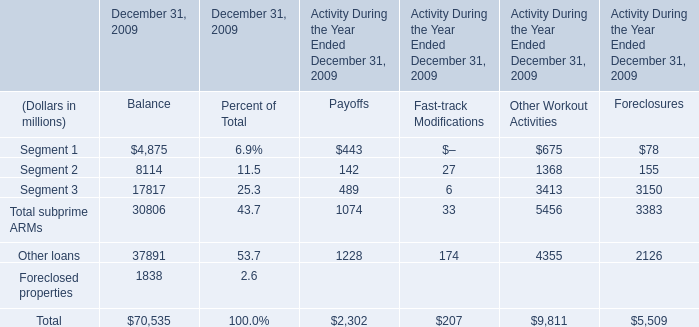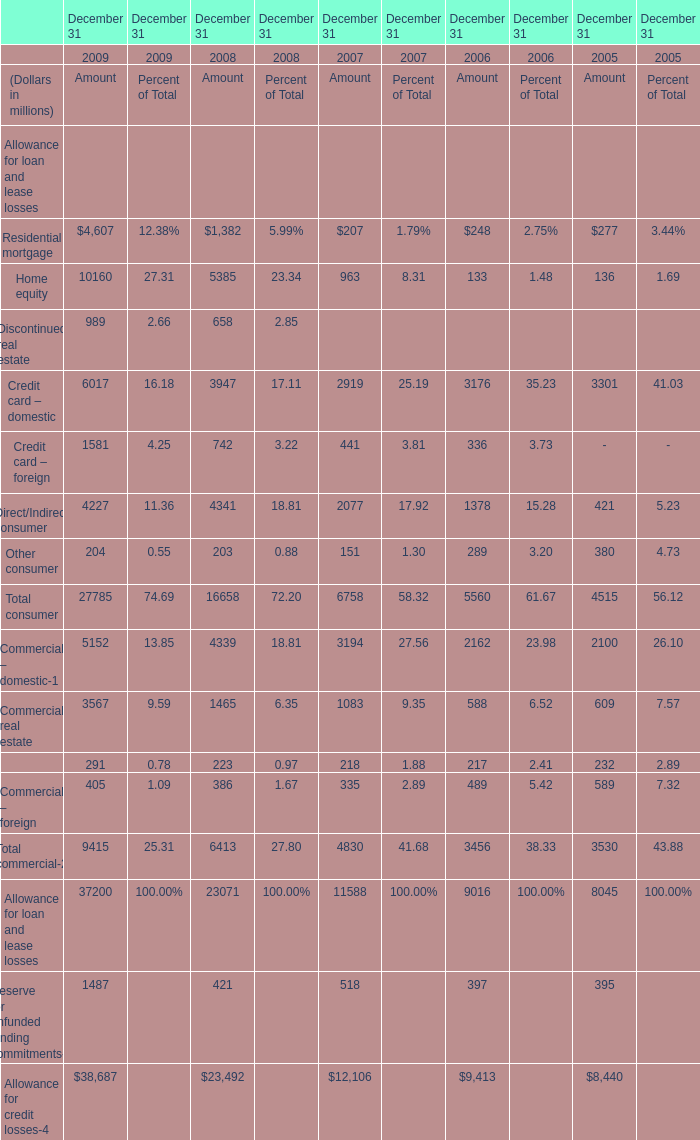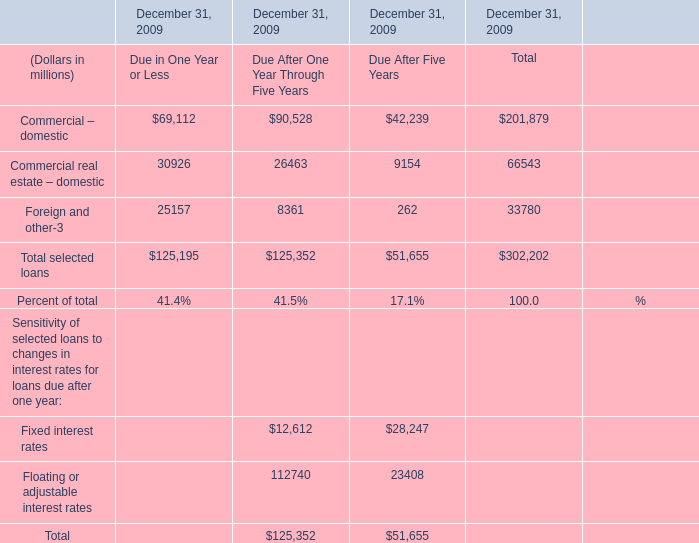If Credit card – domestic develops with the same increasing rate in 2009, what will it reach in 2010? (in million) 
Computations: (6017 * (1 + ((6017 - 3947) / 3947)))
Answer: 9172.60932. 